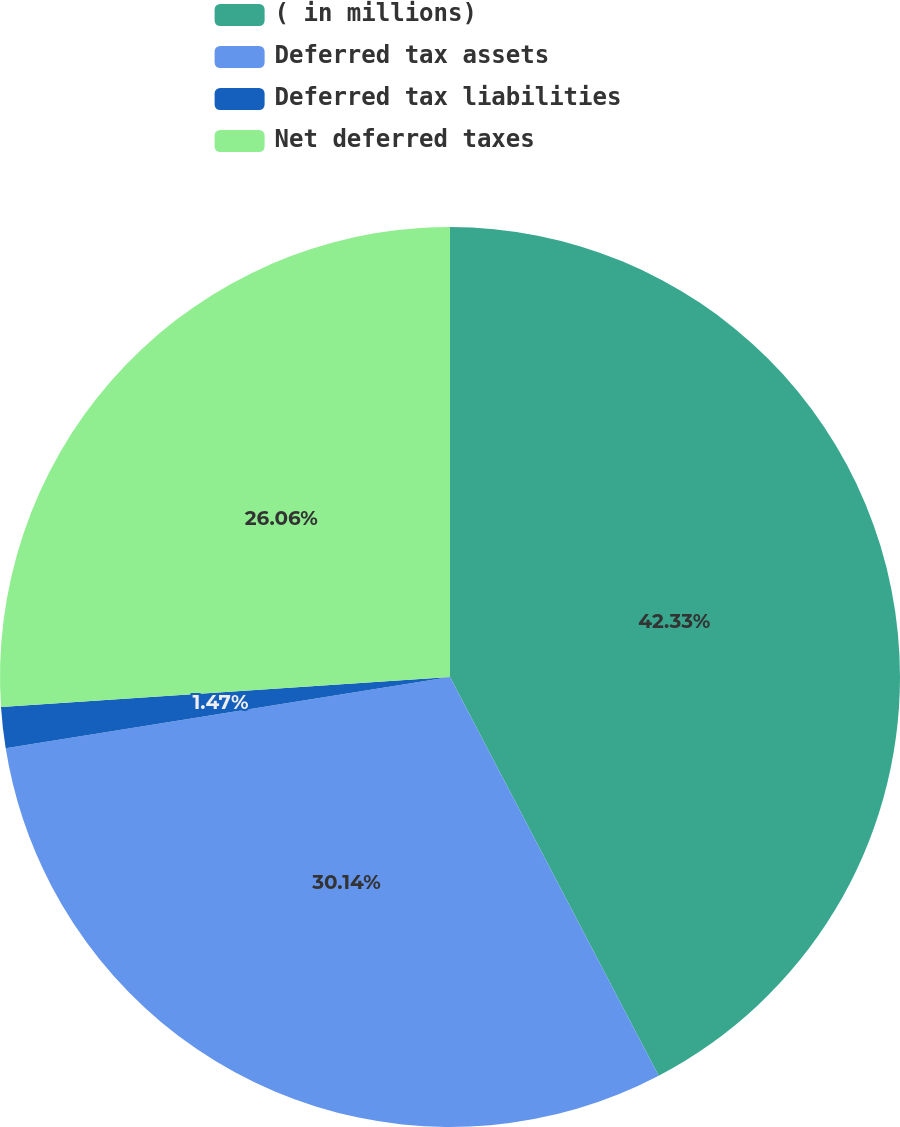<chart> <loc_0><loc_0><loc_500><loc_500><pie_chart><fcel>( in millions)<fcel>Deferred tax assets<fcel>Deferred tax liabilities<fcel>Net deferred taxes<nl><fcel>42.32%<fcel>30.14%<fcel>1.47%<fcel>26.06%<nl></chart> 